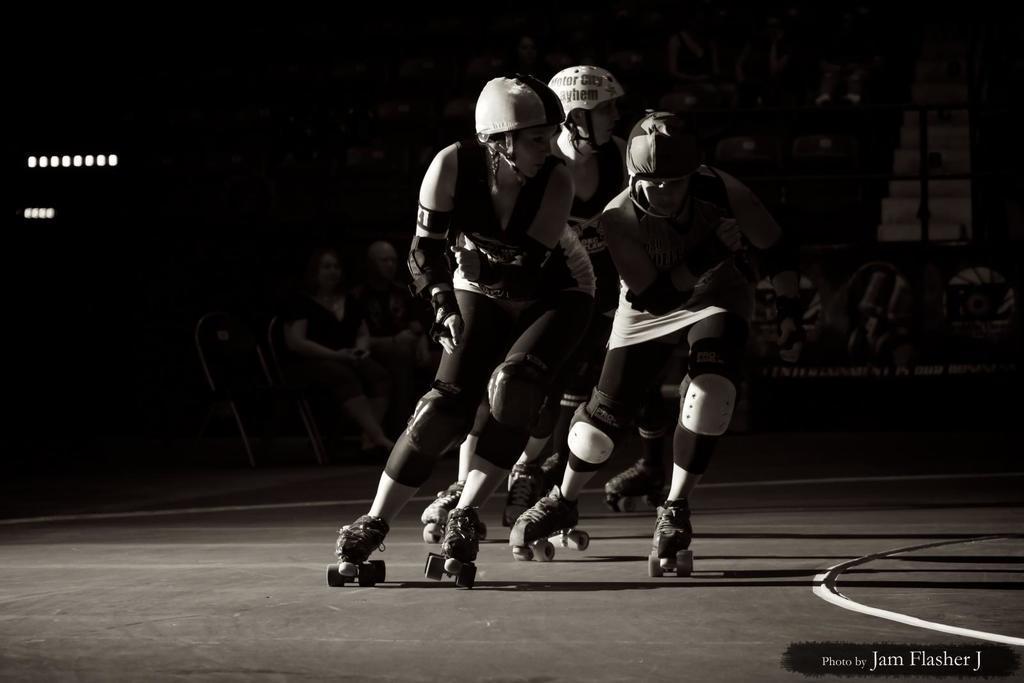Can you describe this image briefly? In the middle of the image few people are skating. Behind them few people are sitting and watching. 